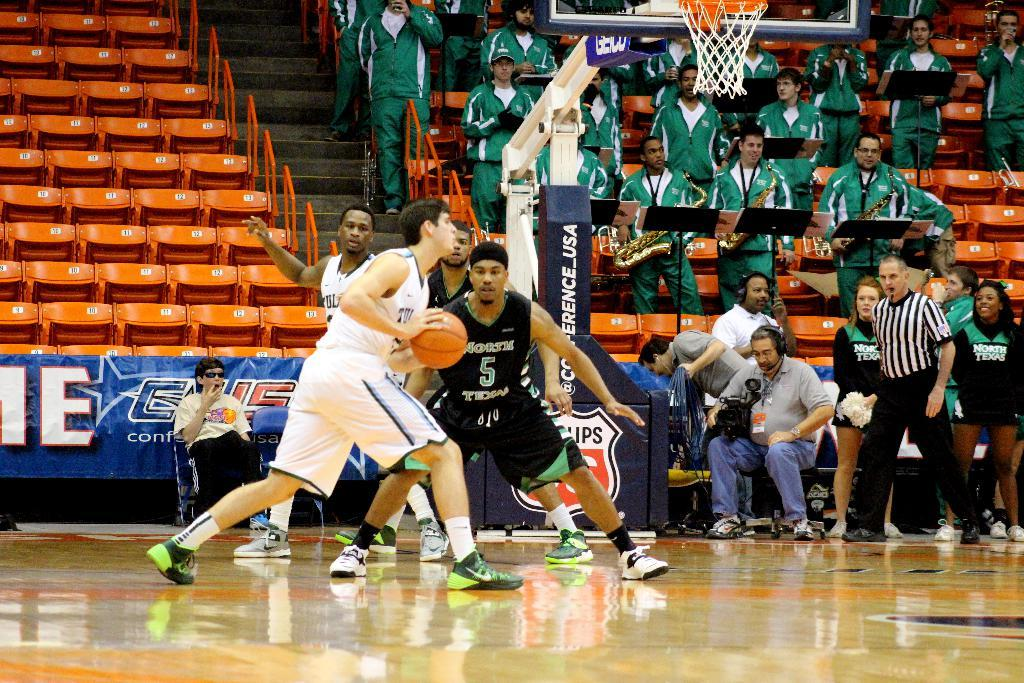<image>
Relay a brief, clear account of the picture shown. Player number 5 for North Texas guards the man in white. 